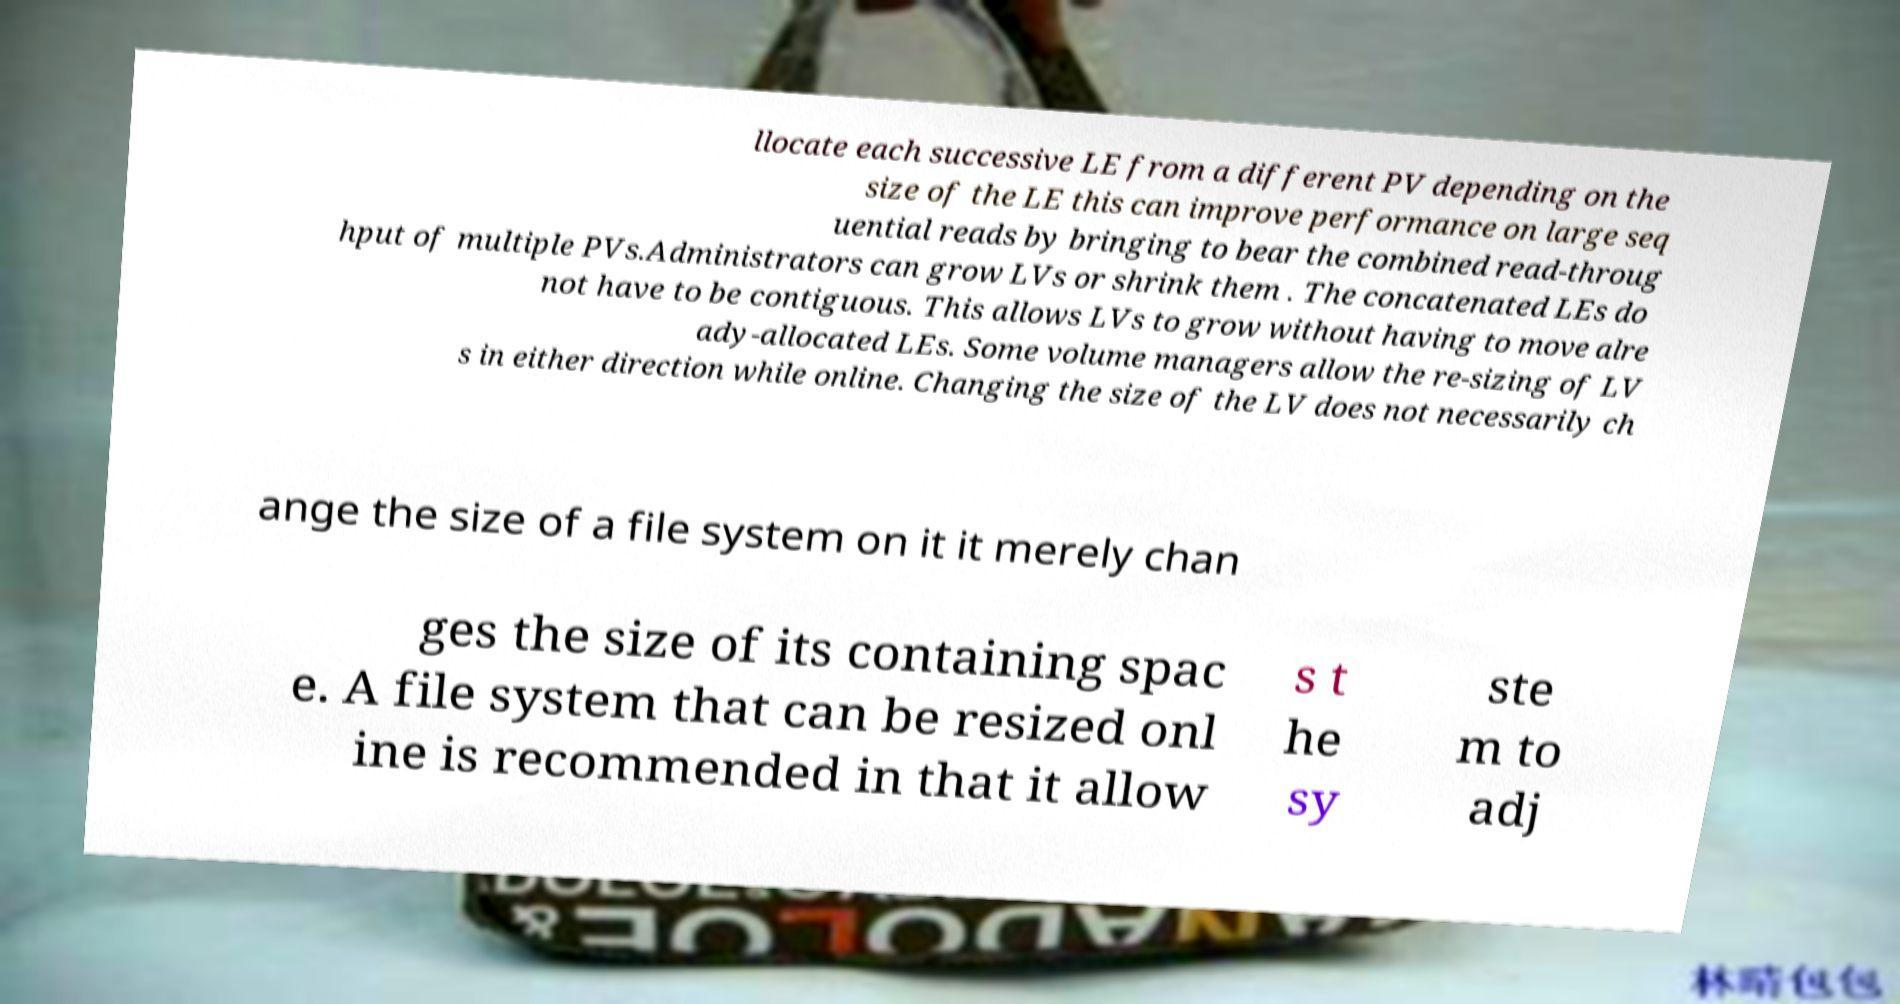For documentation purposes, I need the text within this image transcribed. Could you provide that? llocate each successive LE from a different PV depending on the size of the LE this can improve performance on large seq uential reads by bringing to bear the combined read-throug hput of multiple PVs.Administrators can grow LVs or shrink them . The concatenated LEs do not have to be contiguous. This allows LVs to grow without having to move alre ady-allocated LEs. Some volume managers allow the re-sizing of LV s in either direction while online. Changing the size of the LV does not necessarily ch ange the size of a file system on it it merely chan ges the size of its containing spac e. A file system that can be resized onl ine is recommended in that it allow s t he sy ste m to adj 